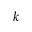<formula> <loc_0><loc_0><loc_500><loc_500>k</formula> 